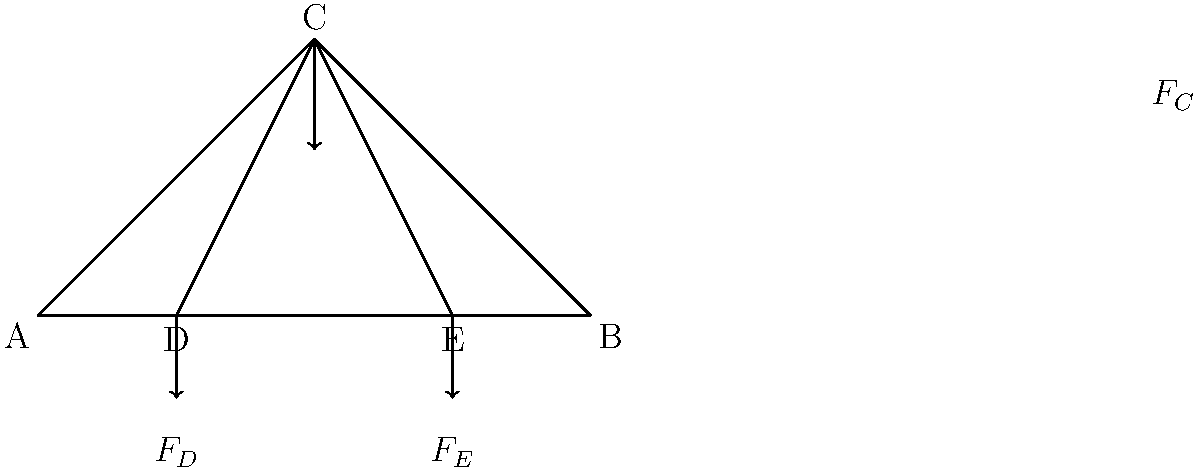In this truss bridge design, if the total load $F_C$ applied at point C is 100 kN, and the bridge is symmetrical, what are the magnitudes of the reaction forces $F_D$ and $F_E$ at points D and E respectively? To solve this problem, we'll use the concept of equilibrium and symmetry in truss structures. Here's a step-by-step explanation:

1) First, note that the truss is symmetrical, and the load $F_C$ is applied at the center point C.

2) Due to symmetry, we can conclude that the reaction forces $F_D$ and $F_E$ will be equal:

   $F_D = F_E$

3) For the structure to be in equilibrium, the sum of all vertical forces must equal zero:

   $\sum F_y = 0$
   $F_C - F_D - F_E = 0$

4) Substituting the known value of $F_C$ and the equality from step 2:

   $100 \text{ kN} - F_D - F_D = 0$
   $100 \text{ kN} - 2F_D = 0$

5) Solving for $F_D$:

   $2F_D = 100 \text{ kN}$
   $F_D = 50 \text{ kN}$

6) Since $F_E = F_D$, we can conclude:

   $F_E = 50 \text{ kN}$

Therefore, both reaction forces $F_D$ and $F_E$ are 50 kN each.
Answer: $F_D = F_E = 50 \text{ kN}$ 